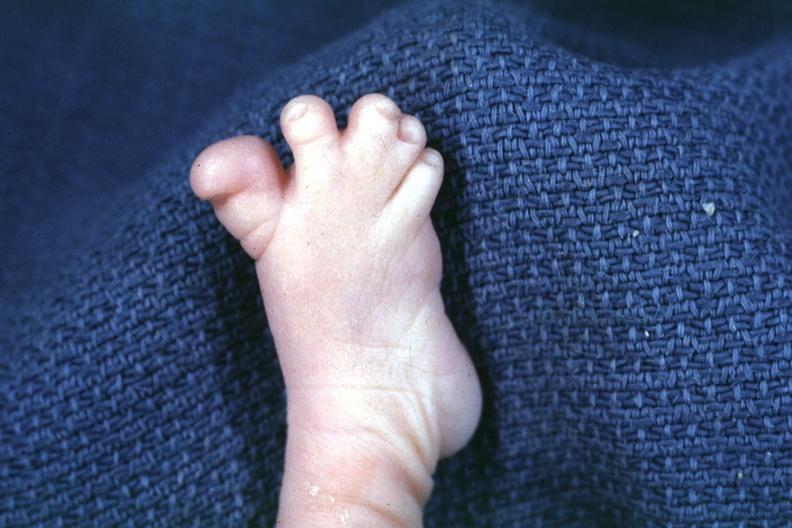does subdiaphragmatic abscess show nice photo of syndactyly?
Answer the question using a single word or phrase. No 